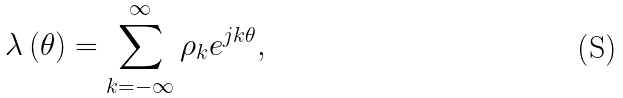Convert formula to latex. <formula><loc_0><loc_0><loc_500><loc_500>\lambda \left ( \theta \right ) = \sum _ { k = - \infty } ^ { \infty } \rho _ { k } e ^ { j k \theta } ,</formula> 